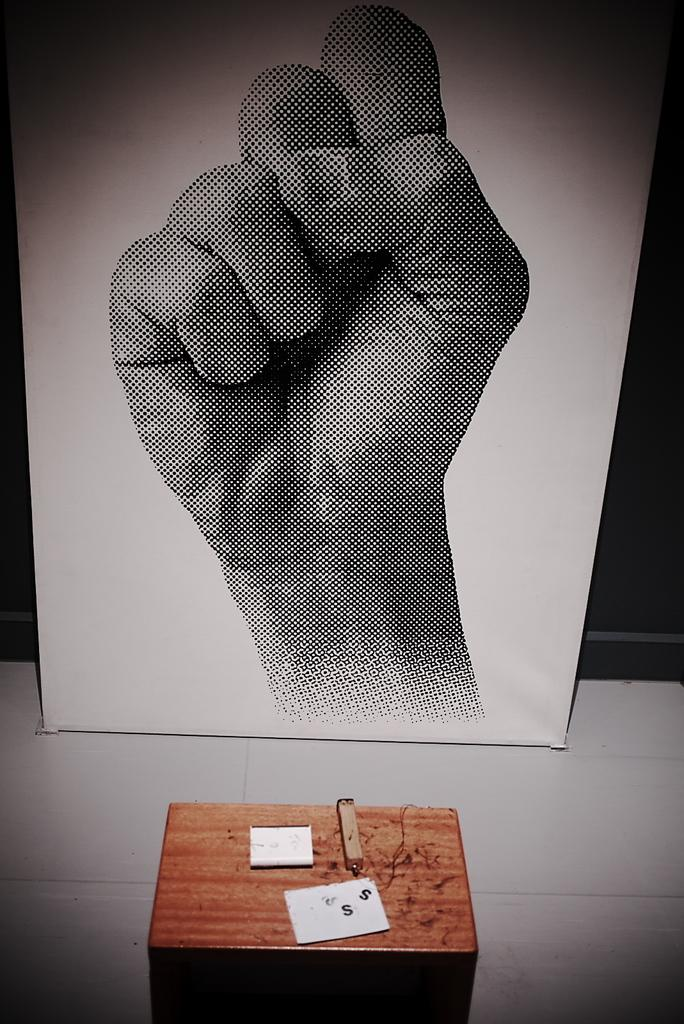What is the main object in the image that stands out? There is a banner or a board in the image that contains an art of a hand. What is the purpose of the banner or board? The purpose of the banner or board is not clear from the image, but it likely serves as a display or advertisement. What is on the table in the image? There is a small wooden table in the image, and on it, there is a card and other objects. Can you describe the card on the table? The card on the table is not described in detail, but it is likely a small piece of paper or cardstock with some text or design. What is the theory behind the disgusting expression on the hand in the image? There is no expression on the hand in the image, and the image does not convey any theory or emotion related to disgust. 